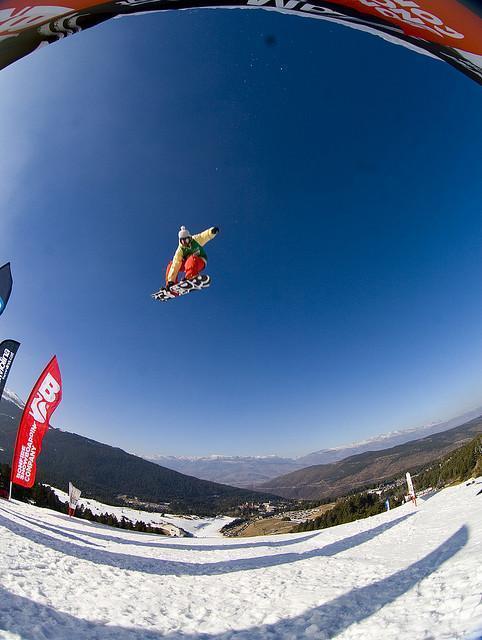How many hands is the snowboarder using to grab his snowboard?
Give a very brief answer. 1. 